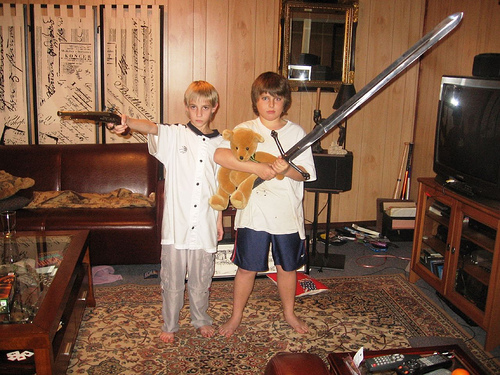What are the two individuals in the photo doing? The two individuals appear to be playfully posing for the photo, one wielding what looks like a large sword, and the other holding a stuffed toy bear. 